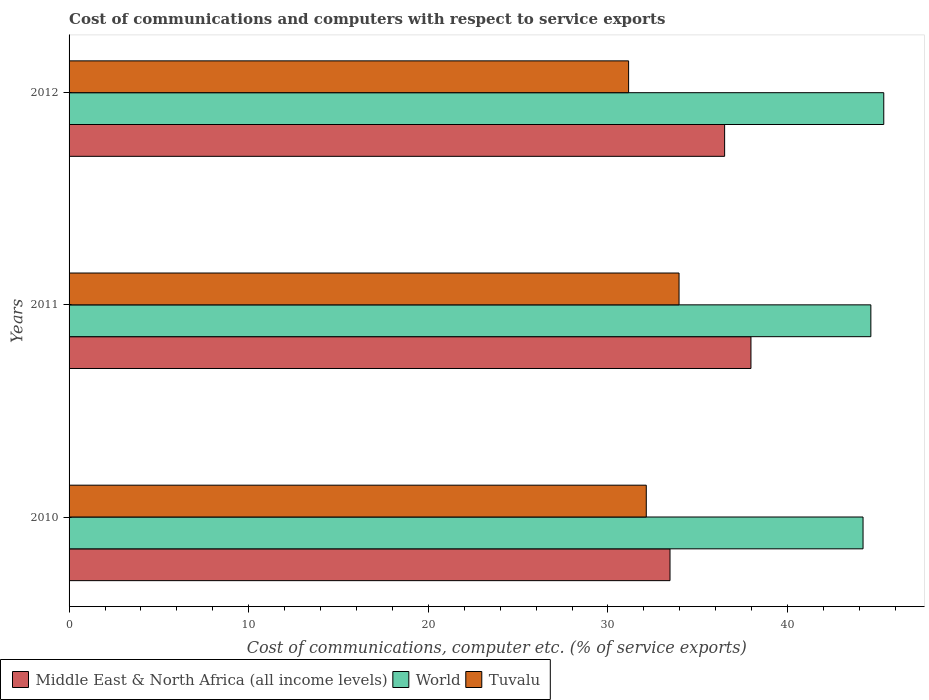How many groups of bars are there?
Ensure brevity in your answer.  3. Are the number of bars on each tick of the Y-axis equal?
Provide a succinct answer. Yes. What is the cost of communications and computers in Middle East & North Africa (all income levels) in 2010?
Offer a very short reply. 33.45. Across all years, what is the maximum cost of communications and computers in Tuvalu?
Offer a terse response. 33.96. Across all years, what is the minimum cost of communications and computers in Tuvalu?
Your answer should be very brief. 31.15. In which year was the cost of communications and computers in Middle East & North Africa (all income levels) maximum?
Your answer should be compact. 2011. What is the total cost of communications and computers in Tuvalu in the graph?
Provide a short and direct response. 97.24. What is the difference between the cost of communications and computers in Middle East & North Africa (all income levels) in 2010 and that in 2011?
Your answer should be very brief. -4.51. What is the difference between the cost of communications and computers in World in 2010 and the cost of communications and computers in Tuvalu in 2012?
Offer a very short reply. 13.05. What is the average cost of communications and computers in Middle East & North Africa (all income levels) per year?
Provide a succinct answer. 35.97. In the year 2012, what is the difference between the cost of communications and computers in World and cost of communications and computers in Tuvalu?
Provide a succinct answer. 14.2. What is the ratio of the cost of communications and computers in Tuvalu in 2010 to that in 2011?
Your response must be concise. 0.95. Is the cost of communications and computers in Middle East & North Africa (all income levels) in 2010 less than that in 2011?
Keep it short and to the point. Yes. Is the difference between the cost of communications and computers in World in 2011 and 2012 greater than the difference between the cost of communications and computers in Tuvalu in 2011 and 2012?
Ensure brevity in your answer.  No. What is the difference between the highest and the second highest cost of communications and computers in Tuvalu?
Give a very brief answer. 1.82. What is the difference between the highest and the lowest cost of communications and computers in World?
Your answer should be compact. 1.15. What does the 1st bar from the top in 2011 represents?
Provide a succinct answer. Tuvalu. What does the 3rd bar from the bottom in 2012 represents?
Your response must be concise. Tuvalu. Is it the case that in every year, the sum of the cost of communications and computers in Middle East & North Africa (all income levels) and cost of communications and computers in World is greater than the cost of communications and computers in Tuvalu?
Provide a short and direct response. Yes. Are all the bars in the graph horizontal?
Offer a very short reply. Yes. Are the values on the major ticks of X-axis written in scientific E-notation?
Offer a terse response. No. How are the legend labels stacked?
Keep it short and to the point. Horizontal. What is the title of the graph?
Provide a succinct answer. Cost of communications and computers with respect to service exports. Does "Bahamas" appear as one of the legend labels in the graph?
Your answer should be very brief. No. What is the label or title of the X-axis?
Provide a succinct answer. Cost of communications, computer etc. (% of service exports). What is the Cost of communications, computer etc. (% of service exports) in Middle East & North Africa (all income levels) in 2010?
Make the answer very short. 33.45. What is the Cost of communications, computer etc. (% of service exports) of World in 2010?
Provide a short and direct response. 44.2. What is the Cost of communications, computer etc. (% of service exports) of Tuvalu in 2010?
Ensure brevity in your answer.  32.13. What is the Cost of communications, computer etc. (% of service exports) of Middle East & North Africa (all income levels) in 2011?
Keep it short and to the point. 37.96. What is the Cost of communications, computer etc. (% of service exports) in World in 2011?
Give a very brief answer. 44.64. What is the Cost of communications, computer etc. (% of service exports) in Tuvalu in 2011?
Ensure brevity in your answer.  33.96. What is the Cost of communications, computer etc. (% of service exports) in Middle East & North Africa (all income levels) in 2012?
Ensure brevity in your answer.  36.49. What is the Cost of communications, computer etc. (% of service exports) in World in 2012?
Keep it short and to the point. 45.35. What is the Cost of communications, computer etc. (% of service exports) of Tuvalu in 2012?
Your answer should be compact. 31.15. Across all years, what is the maximum Cost of communications, computer etc. (% of service exports) in Middle East & North Africa (all income levels)?
Provide a short and direct response. 37.96. Across all years, what is the maximum Cost of communications, computer etc. (% of service exports) in World?
Offer a very short reply. 45.35. Across all years, what is the maximum Cost of communications, computer etc. (% of service exports) of Tuvalu?
Offer a terse response. 33.96. Across all years, what is the minimum Cost of communications, computer etc. (% of service exports) in Middle East & North Africa (all income levels)?
Keep it short and to the point. 33.45. Across all years, what is the minimum Cost of communications, computer etc. (% of service exports) of World?
Keep it short and to the point. 44.2. Across all years, what is the minimum Cost of communications, computer etc. (% of service exports) of Tuvalu?
Keep it short and to the point. 31.15. What is the total Cost of communications, computer etc. (% of service exports) in Middle East & North Africa (all income levels) in the graph?
Provide a succinct answer. 107.91. What is the total Cost of communications, computer etc. (% of service exports) of World in the graph?
Provide a succinct answer. 134.19. What is the total Cost of communications, computer etc. (% of service exports) in Tuvalu in the graph?
Ensure brevity in your answer.  97.24. What is the difference between the Cost of communications, computer etc. (% of service exports) in Middle East & North Africa (all income levels) in 2010 and that in 2011?
Provide a succinct answer. -4.51. What is the difference between the Cost of communications, computer etc. (% of service exports) of World in 2010 and that in 2011?
Your answer should be compact. -0.44. What is the difference between the Cost of communications, computer etc. (% of service exports) of Tuvalu in 2010 and that in 2011?
Ensure brevity in your answer.  -1.82. What is the difference between the Cost of communications, computer etc. (% of service exports) in Middle East & North Africa (all income levels) in 2010 and that in 2012?
Keep it short and to the point. -3.04. What is the difference between the Cost of communications, computer etc. (% of service exports) in World in 2010 and that in 2012?
Provide a short and direct response. -1.15. What is the difference between the Cost of communications, computer etc. (% of service exports) in Tuvalu in 2010 and that in 2012?
Your response must be concise. 0.98. What is the difference between the Cost of communications, computer etc. (% of service exports) of Middle East & North Africa (all income levels) in 2011 and that in 2012?
Make the answer very short. 1.47. What is the difference between the Cost of communications, computer etc. (% of service exports) of World in 2011 and that in 2012?
Your answer should be very brief. -0.72. What is the difference between the Cost of communications, computer etc. (% of service exports) in Tuvalu in 2011 and that in 2012?
Your answer should be very brief. 2.81. What is the difference between the Cost of communications, computer etc. (% of service exports) in Middle East & North Africa (all income levels) in 2010 and the Cost of communications, computer etc. (% of service exports) in World in 2011?
Your answer should be compact. -11.18. What is the difference between the Cost of communications, computer etc. (% of service exports) in Middle East & North Africa (all income levels) in 2010 and the Cost of communications, computer etc. (% of service exports) in Tuvalu in 2011?
Give a very brief answer. -0.5. What is the difference between the Cost of communications, computer etc. (% of service exports) of World in 2010 and the Cost of communications, computer etc. (% of service exports) of Tuvalu in 2011?
Offer a very short reply. 10.24. What is the difference between the Cost of communications, computer etc. (% of service exports) of Middle East & North Africa (all income levels) in 2010 and the Cost of communications, computer etc. (% of service exports) of World in 2012?
Provide a succinct answer. -11.9. What is the difference between the Cost of communications, computer etc. (% of service exports) in Middle East & North Africa (all income levels) in 2010 and the Cost of communications, computer etc. (% of service exports) in Tuvalu in 2012?
Keep it short and to the point. 2.3. What is the difference between the Cost of communications, computer etc. (% of service exports) in World in 2010 and the Cost of communications, computer etc. (% of service exports) in Tuvalu in 2012?
Offer a very short reply. 13.05. What is the difference between the Cost of communications, computer etc. (% of service exports) in Middle East & North Africa (all income levels) in 2011 and the Cost of communications, computer etc. (% of service exports) in World in 2012?
Offer a very short reply. -7.39. What is the difference between the Cost of communications, computer etc. (% of service exports) in Middle East & North Africa (all income levels) in 2011 and the Cost of communications, computer etc. (% of service exports) in Tuvalu in 2012?
Ensure brevity in your answer.  6.81. What is the difference between the Cost of communications, computer etc. (% of service exports) in World in 2011 and the Cost of communications, computer etc. (% of service exports) in Tuvalu in 2012?
Your response must be concise. 13.49. What is the average Cost of communications, computer etc. (% of service exports) in Middle East & North Africa (all income levels) per year?
Make the answer very short. 35.97. What is the average Cost of communications, computer etc. (% of service exports) in World per year?
Ensure brevity in your answer.  44.73. What is the average Cost of communications, computer etc. (% of service exports) of Tuvalu per year?
Ensure brevity in your answer.  32.41. In the year 2010, what is the difference between the Cost of communications, computer etc. (% of service exports) in Middle East & North Africa (all income levels) and Cost of communications, computer etc. (% of service exports) in World?
Offer a very short reply. -10.75. In the year 2010, what is the difference between the Cost of communications, computer etc. (% of service exports) of Middle East & North Africa (all income levels) and Cost of communications, computer etc. (% of service exports) of Tuvalu?
Provide a short and direct response. 1.32. In the year 2010, what is the difference between the Cost of communications, computer etc. (% of service exports) in World and Cost of communications, computer etc. (% of service exports) in Tuvalu?
Make the answer very short. 12.07. In the year 2011, what is the difference between the Cost of communications, computer etc. (% of service exports) in Middle East & North Africa (all income levels) and Cost of communications, computer etc. (% of service exports) in World?
Provide a short and direct response. -6.68. In the year 2011, what is the difference between the Cost of communications, computer etc. (% of service exports) of Middle East & North Africa (all income levels) and Cost of communications, computer etc. (% of service exports) of Tuvalu?
Your response must be concise. 4. In the year 2011, what is the difference between the Cost of communications, computer etc. (% of service exports) of World and Cost of communications, computer etc. (% of service exports) of Tuvalu?
Your response must be concise. 10.68. In the year 2012, what is the difference between the Cost of communications, computer etc. (% of service exports) of Middle East & North Africa (all income levels) and Cost of communications, computer etc. (% of service exports) of World?
Provide a succinct answer. -8.86. In the year 2012, what is the difference between the Cost of communications, computer etc. (% of service exports) of Middle East & North Africa (all income levels) and Cost of communications, computer etc. (% of service exports) of Tuvalu?
Your response must be concise. 5.34. In the year 2012, what is the difference between the Cost of communications, computer etc. (% of service exports) of World and Cost of communications, computer etc. (% of service exports) of Tuvalu?
Offer a very short reply. 14.2. What is the ratio of the Cost of communications, computer etc. (% of service exports) in Middle East & North Africa (all income levels) in 2010 to that in 2011?
Provide a short and direct response. 0.88. What is the ratio of the Cost of communications, computer etc. (% of service exports) of World in 2010 to that in 2011?
Your answer should be very brief. 0.99. What is the ratio of the Cost of communications, computer etc. (% of service exports) of Tuvalu in 2010 to that in 2011?
Give a very brief answer. 0.95. What is the ratio of the Cost of communications, computer etc. (% of service exports) in Middle East & North Africa (all income levels) in 2010 to that in 2012?
Provide a succinct answer. 0.92. What is the ratio of the Cost of communications, computer etc. (% of service exports) in World in 2010 to that in 2012?
Make the answer very short. 0.97. What is the ratio of the Cost of communications, computer etc. (% of service exports) in Tuvalu in 2010 to that in 2012?
Your answer should be compact. 1.03. What is the ratio of the Cost of communications, computer etc. (% of service exports) in Middle East & North Africa (all income levels) in 2011 to that in 2012?
Provide a succinct answer. 1.04. What is the ratio of the Cost of communications, computer etc. (% of service exports) of World in 2011 to that in 2012?
Give a very brief answer. 0.98. What is the ratio of the Cost of communications, computer etc. (% of service exports) of Tuvalu in 2011 to that in 2012?
Give a very brief answer. 1.09. What is the difference between the highest and the second highest Cost of communications, computer etc. (% of service exports) of Middle East & North Africa (all income levels)?
Provide a succinct answer. 1.47. What is the difference between the highest and the second highest Cost of communications, computer etc. (% of service exports) in World?
Keep it short and to the point. 0.72. What is the difference between the highest and the second highest Cost of communications, computer etc. (% of service exports) of Tuvalu?
Your answer should be very brief. 1.82. What is the difference between the highest and the lowest Cost of communications, computer etc. (% of service exports) in Middle East & North Africa (all income levels)?
Ensure brevity in your answer.  4.51. What is the difference between the highest and the lowest Cost of communications, computer etc. (% of service exports) in World?
Offer a very short reply. 1.15. What is the difference between the highest and the lowest Cost of communications, computer etc. (% of service exports) of Tuvalu?
Keep it short and to the point. 2.81. 